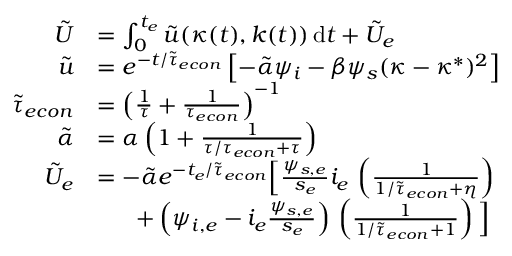Convert formula to latex. <formula><loc_0><loc_0><loc_500><loc_500>\begin{array} { r l } { \tilde { U } } & { = \int _ { 0 } ^ { t _ { e } } \tilde { u } ( \kappa ( t ) , k ( t ) ) \, d t + \tilde { U } _ { e } } \\ { \tilde { u } } & { = e ^ { - t / \tilde { \tau } _ { e c o n } } \left [ - \tilde { \alpha } \psi _ { i } - \beta \psi _ { s } ( \kappa - \kappa ^ { * } ) ^ { 2 } \right ] } \\ { \tilde { \tau } _ { e c o n } } & { = \left ( \frac { 1 } { \tau } + \frac { 1 } { \tau _ { e c o n } } \right ) ^ { - 1 } } \\ { \tilde { \alpha } } & { = \alpha \left ( 1 + \frac { 1 } { \tau / { \tau _ { e c o n } } + \tau } \right ) } \\ { \tilde { U } _ { e } } & { = - \tilde { \alpha } e ^ { - t _ { e } / \tilde { \tau } _ { e c o n } } \left [ \frac { \psi _ { s , e } } { s _ { e } } i _ { e } \, \left ( \frac { 1 } { 1 / \tilde { \tau } _ { e c o n } + \eta } \right ) } \\ & { \quad \ + \left ( \psi _ { i , e } - i _ { e } \frac { \psi _ { s , e } } { s _ { e } } \right ) \, \left ( \frac { 1 } { 1 / \tilde { \tau } _ { e c o n } + 1 } \right ) \right ] } \end{array}</formula> 